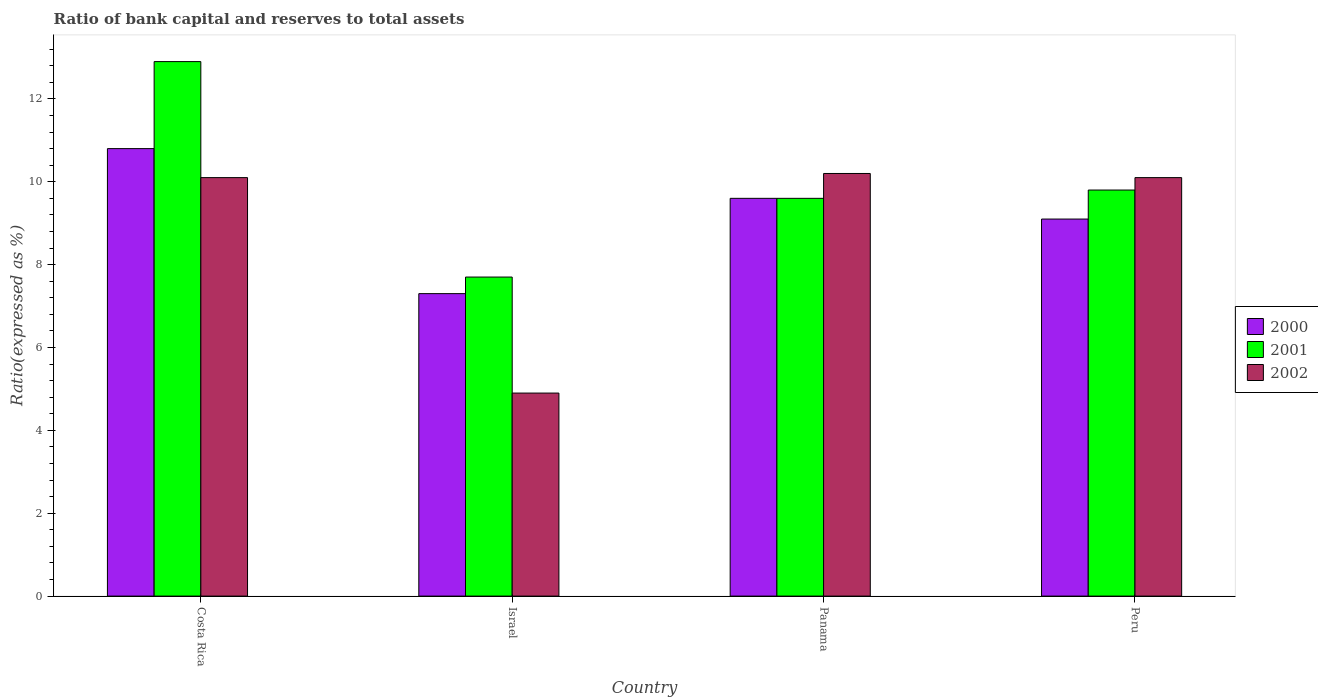How many bars are there on the 2nd tick from the left?
Offer a terse response. 3. What is the ratio of bank capital and reserves to total assets in 2001 in Israel?
Your answer should be compact. 7.7. Across all countries, what is the maximum ratio of bank capital and reserves to total assets in 2001?
Provide a short and direct response. 12.9. Across all countries, what is the minimum ratio of bank capital and reserves to total assets in 2001?
Offer a very short reply. 7.7. In which country was the ratio of bank capital and reserves to total assets in 2002 maximum?
Ensure brevity in your answer.  Panama. What is the total ratio of bank capital and reserves to total assets in 2002 in the graph?
Make the answer very short. 35.3. What is the difference between the ratio of bank capital and reserves to total assets in 2001 in Israel and that in Peru?
Provide a succinct answer. -2.1. What is the difference between the ratio of bank capital and reserves to total assets in 2000 in Costa Rica and the ratio of bank capital and reserves to total assets in 2002 in Panama?
Make the answer very short. 0.6. What is the average ratio of bank capital and reserves to total assets in 2002 per country?
Provide a short and direct response. 8.82. What is the difference between the ratio of bank capital and reserves to total assets of/in 2001 and ratio of bank capital and reserves to total assets of/in 2002 in Panama?
Your answer should be compact. -0.6. In how many countries, is the ratio of bank capital and reserves to total assets in 2001 greater than 9.2 %?
Provide a succinct answer. 3. What is the ratio of the ratio of bank capital and reserves to total assets in 2000 in Costa Rica to that in Panama?
Your response must be concise. 1.13. Is the ratio of bank capital and reserves to total assets in 2001 in Costa Rica less than that in Peru?
Offer a terse response. No. Is the difference between the ratio of bank capital and reserves to total assets in 2001 in Panama and Peru greater than the difference between the ratio of bank capital and reserves to total assets in 2002 in Panama and Peru?
Give a very brief answer. No. What is the difference between the highest and the second highest ratio of bank capital and reserves to total assets in 2000?
Make the answer very short. -1.2. What is the difference between the highest and the lowest ratio of bank capital and reserves to total assets in 2002?
Make the answer very short. 5.3. In how many countries, is the ratio of bank capital and reserves to total assets in 2001 greater than the average ratio of bank capital and reserves to total assets in 2001 taken over all countries?
Provide a succinct answer. 1. What does the 1st bar from the left in Peru represents?
Offer a terse response. 2000. What does the 2nd bar from the right in Peru represents?
Your response must be concise. 2001. Is it the case that in every country, the sum of the ratio of bank capital and reserves to total assets in 2001 and ratio of bank capital and reserves to total assets in 2002 is greater than the ratio of bank capital and reserves to total assets in 2000?
Offer a terse response. Yes. Are all the bars in the graph horizontal?
Make the answer very short. No. What is the difference between two consecutive major ticks on the Y-axis?
Make the answer very short. 2. Are the values on the major ticks of Y-axis written in scientific E-notation?
Your answer should be compact. No. Does the graph contain any zero values?
Keep it short and to the point. No. Where does the legend appear in the graph?
Your answer should be compact. Center right. What is the title of the graph?
Provide a succinct answer. Ratio of bank capital and reserves to total assets. What is the label or title of the Y-axis?
Your response must be concise. Ratio(expressed as %). What is the Ratio(expressed as %) in 2001 in Costa Rica?
Give a very brief answer. 12.9. What is the Ratio(expressed as %) of 2002 in Costa Rica?
Your answer should be very brief. 10.1. What is the Ratio(expressed as %) in 2000 in Israel?
Keep it short and to the point. 7.3. What is the Ratio(expressed as %) in 2002 in Israel?
Keep it short and to the point. 4.9. What is the Ratio(expressed as %) of 2002 in Panama?
Provide a short and direct response. 10.2. What is the Ratio(expressed as %) in 2002 in Peru?
Provide a short and direct response. 10.1. Across all countries, what is the minimum Ratio(expressed as %) of 2000?
Provide a succinct answer. 7.3. Across all countries, what is the minimum Ratio(expressed as %) of 2001?
Provide a succinct answer. 7.7. What is the total Ratio(expressed as %) in 2000 in the graph?
Provide a short and direct response. 36.8. What is the total Ratio(expressed as %) of 2001 in the graph?
Make the answer very short. 40. What is the total Ratio(expressed as %) of 2002 in the graph?
Make the answer very short. 35.3. What is the difference between the Ratio(expressed as %) of 2000 in Costa Rica and that in Israel?
Give a very brief answer. 3.5. What is the difference between the Ratio(expressed as %) in 2001 in Costa Rica and that in Israel?
Make the answer very short. 5.2. What is the difference between the Ratio(expressed as %) in 2000 in Costa Rica and that in Panama?
Make the answer very short. 1.2. What is the difference between the Ratio(expressed as %) of 2001 in Costa Rica and that in Panama?
Make the answer very short. 3.3. What is the difference between the Ratio(expressed as %) of 2002 in Costa Rica and that in Panama?
Make the answer very short. -0.1. What is the difference between the Ratio(expressed as %) in 2000 in Costa Rica and that in Peru?
Make the answer very short. 1.7. What is the difference between the Ratio(expressed as %) in 2001 in Israel and that in Panama?
Offer a very short reply. -1.9. What is the difference between the Ratio(expressed as %) of 2002 in Israel and that in Panama?
Keep it short and to the point. -5.3. What is the difference between the Ratio(expressed as %) of 2002 in Israel and that in Peru?
Offer a very short reply. -5.2. What is the difference between the Ratio(expressed as %) in 2000 in Panama and that in Peru?
Give a very brief answer. 0.5. What is the difference between the Ratio(expressed as %) in 2002 in Panama and that in Peru?
Your answer should be compact. 0.1. What is the difference between the Ratio(expressed as %) of 2000 in Costa Rica and the Ratio(expressed as %) of 2001 in Israel?
Your response must be concise. 3.1. What is the difference between the Ratio(expressed as %) in 2000 in Costa Rica and the Ratio(expressed as %) in 2002 in Israel?
Your answer should be compact. 5.9. What is the difference between the Ratio(expressed as %) in 2000 in Costa Rica and the Ratio(expressed as %) in 2002 in Peru?
Keep it short and to the point. 0.7. What is the difference between the Ratio(expressed as %) of 2000 in Israel and the Ratio(expressed as %) of 2001 in Panama?
Your response must be concise. -2.3. What is the difference between the Ratio(expressed as %) in 2000 in Israel and the Ratio(expressed as %) in 2002 in Panama?
Make the answer very short. -2.9. What is the difference between the Ratio(expressed as %) in 2000 in Israel and the Ratio(expressed as %) in 2002 in Peru?
Offer a terse response. -2.8. What is the difference between the Ratio(expressed as %) of 2001 in Israel and the Ratio(expressed as %) of 2002 in Peru?
Your answer should be compact. -2.4. What is the difference between the Ratio(expressed as %) in 2000 in Panama and the Ratio(expressed as %) in 2001 in Peru?
Offer a very short reply. -0.2. What is the difference between the Ratio(expressed as %) of 2000 in Panama and the Ratio(expressed as %) of 2002 in Peru?
Keep it short and to the point. -0.5. What is the difference between the Ratio(expressed as %) of 2001 in Panama and the Ratio(expressed as %) of 2002 in Peru?
Your answer should be very brief. -0.5. What is the average Ratio(expressed as %) in 2001 per country?
Give a very brief answer. 10. What is the average Ratio(expressed as %) of 2002 per country?
Keep it short and to the point. 8.82. What is the difference between the Ratio(expressed as %) in 2000 and Ratio(expressed as %) in 2001 in Costa Rica?
Your answer should be very brief. -2.1. What is the difference between the Ratio(expressed as %) in 2000 and Ratio(expressed as %) in 2002 in Costa Rica?
Your answer should be very brief. 0.7. What is the difference between the Ratio(expressed as %) in 2001 and Ratio(expressed as %) in 2002 in Costa Rica?
Offer a terse response. 2.8. What is the difference between the Ratio(expressed as %) in 2001 and Ratio(expressed as %) in 2002 in Israel?
Give a very brief answer. 2.8. What is the difference between the Ratio(expressed as %) in 2001 and Ratio(expressed as %) in 2002 in Peru?
Ensure brevity in your answer.  -0.3. What is the ratio of the Ratio(expressed as %) in 2000 in Costa Rica to that in Israel?
Offer a terse response. 1.48. What is the ratio of the Ratio(expressed as %) in 2001 in Costa Rica to that in Israel?
Make the answer very short. 1.68. What is the ratio of the Ratio(expressed as %) in 2002 in Costa Rica to that in Israel?
Make the answer very short. 2.06. What is the ratio of the Ratio(expressed as %) of 2001 in Costa Rica to that in Panama?
Make the answer very short. 1.34. What is the ratio of the Ratio(expressed as %) in 2002 in Costa Rica to that in Panama?
Make the answer very short. 0.99. What is the ratio of the Ratio(expressed as %) of 2000 in Costa Rica to that in Peru?
Provide a succinct answer. 1.19. What is the ratio of the Ratio(expressed as %) in 2001 in Costa Rica to that in Peru?
Offer a terse response. 1.32. What is the ratio of the Ratio(expressed as %) in 2000 in Israel to that in Panama?
Give a very brief answer. 0.76. What is the ratio of the Ratio(expressed as %) in 2001 in Israel to that in Panama?
Give a very brief answer. 0.8. What is the ratio of the Ratio(expressed as %) of 2002 in Israel to that in Panama?
Give a very brief answer. 0.48. What is the ratio of the Ratio(expressed as %) in 2000 in Israel to that in Peru?
Offer a terse response. 0.8. What is the ratio of the Ratio(expressed as %) of 2001 in Israel to that in Peru?
Offer a very short reply. 0.79. What is the ratio of the Ratio(expressed as %) in 2002 in Israel to that in Peru?
Make the answer very short. 0.49. What is the ratio of the Ratio(expressed as %) of 2000 in Panama to that in Peru?
Offer a very short reply. 1.05. What is the ratio of the Ratio(expressed as %) in 2001 in Panama to that in Peru?
Ensure brevity in your answer.  0.98. What is the ratio of the Ratio(expressed as %) of 2002 in Panama to that in Peru?
Offer a very short reply. 1.01. What is the difference between the highest and the second highest Ratio(expressed as %) of 2000?
Ensure brevity in your answer.  1.2. What is the difference between the highest and the lowest Ratio(expressed as %) of 2000?
Give a very brief answer. 3.5. What is the difference between the highest and the lowest Ratio(expressed as %) in 2002?
Keep it short and to the point. 5.3. 